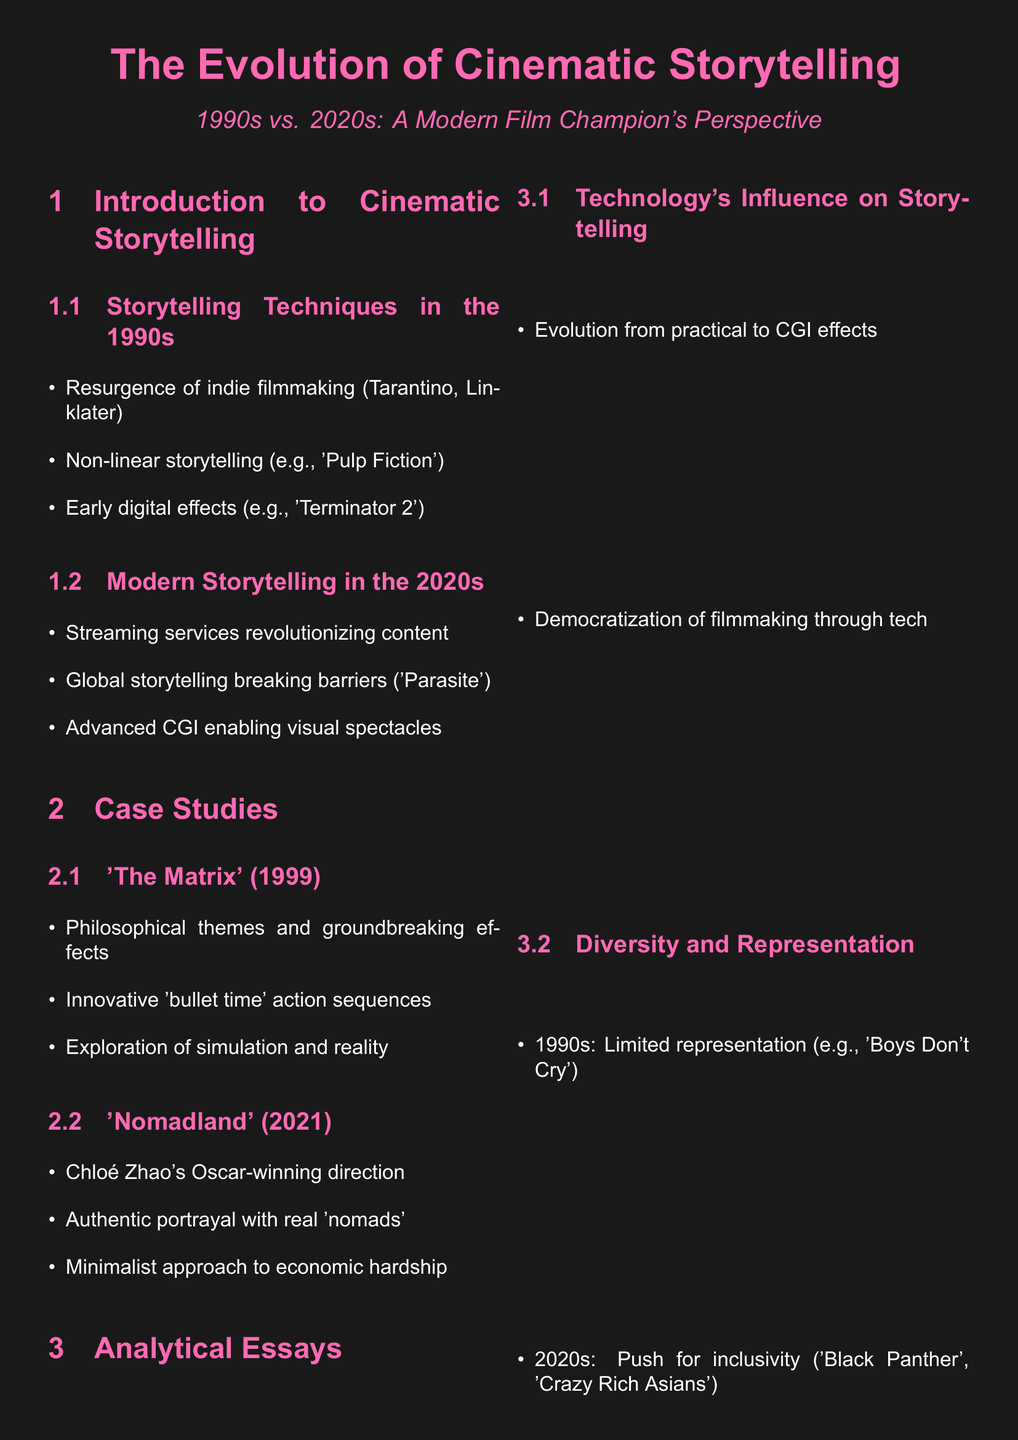What are two notable filmmakers mentioned for the 1990s? The document lists Tarantino and Linklater as significant indie filmmakers from the 1990s.
Answer: Tarantino, Linklater What is one film that exemplifies non-linear storytelling from the 1990s? 'Pulp Fiction' is cited as an example of non-linear storytelling in the 1990s.
Answer: 'Pulp Fiction' Which film from the 2020s is highlighted for its authentic portrayal using real 'nomads'? The document mentions 'Nomadland' for its authentic representation of individuals living as nomads.
Answer: 'Nomadland' In what year was 'The Matrix' released? The release year of 'The Matrix' is stated as 1999.
Answer: 1999 What technology advancement is emphasized in the transition from the 1990s to 2020s filmmaking? The document notes the evolution from practical effects to CGI effects as a key technological change in filmmaking.
Answer: CGI effects Which film represents the push for inclusivity in the 2020s? 'Black Panther' is identified as a significant film representing inclusivity in modern cinema.
Answer: 'Black Panther' What critical theme does 'The Matrix' explore? The document indicates that 'The Matrix' delves into themes of simulation and reality.
Answer: Simulation and reality How did the role of streaming services change cinematic storytelling? The document refers to streaming services as a revolutionary factor in modern cinematic storytelling.
Answer: Revolutionized content What was a limitation of representation in the 1990s as noted in the document? The document mentions limited representation as a notable issue in 1990s cinema.
Answer: Limited representation 